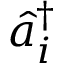<formula> <loc_0><loc_0><loc_500><loc_500>\hat { a } _ { i } ^ { \dagger }</formula> 